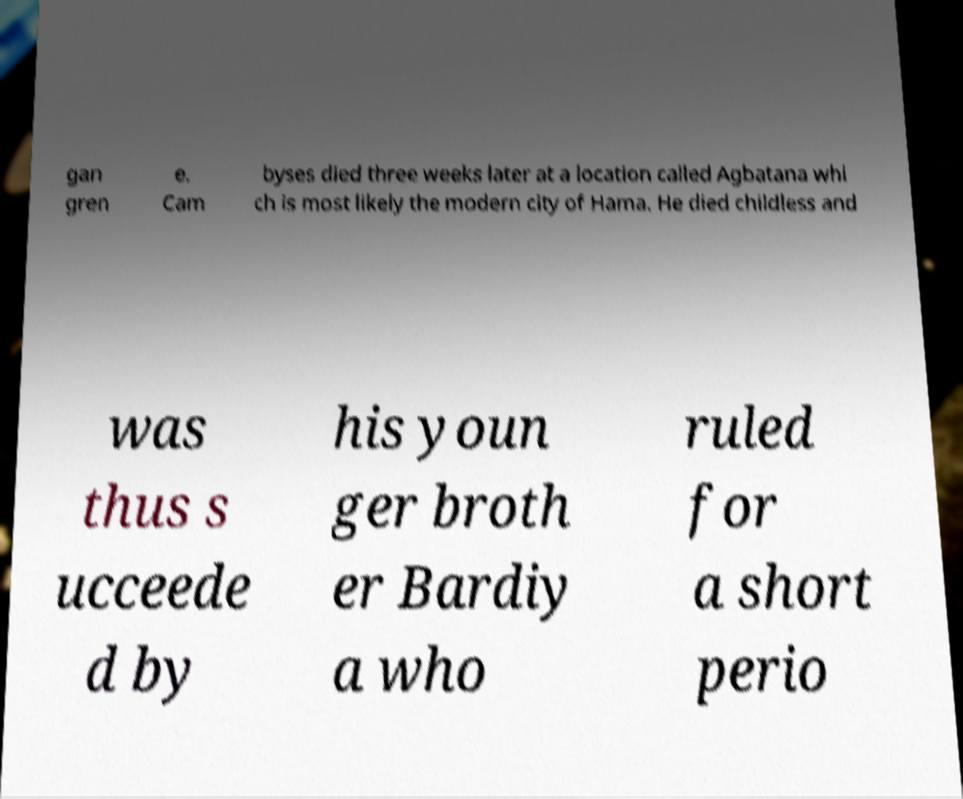Please identify and transcribe the text found in this image. gan gren e. Cam byses died three weeks later at a location called Agbatana whi ch is most likely the modern city of Hama. He died childless and was thus s ucceede d by his youn ger broth er Bardiy a who ruled for a short perio 